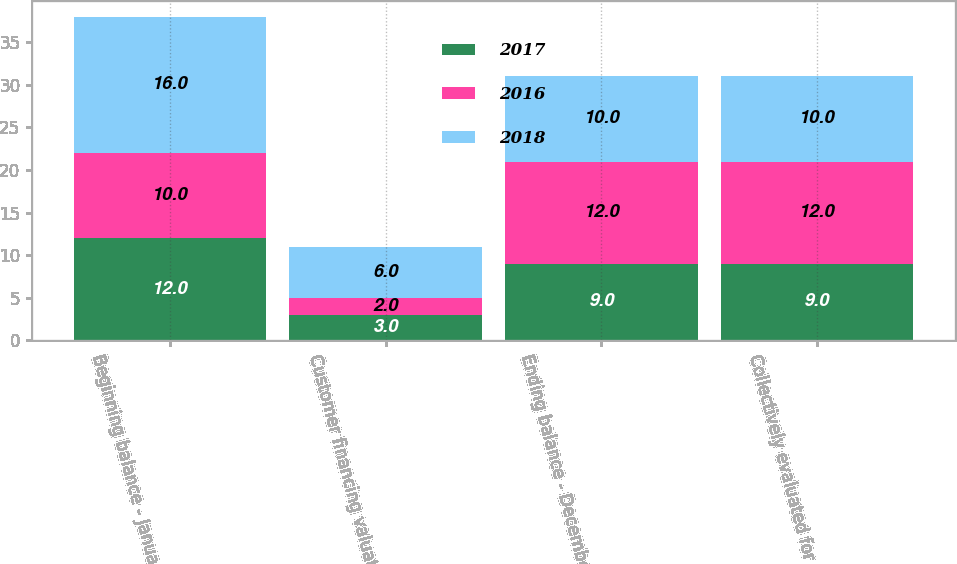<chart> <loc_0><loc_0><loc_500><loc_500><stacked_bar_chart><ecel><fcel>Beginning balance - January 1<fcel>Customer financing valuation<fcel>Ending balance - December 31<fcel>Collectively evaluated for<nl><fcel>2017<fcel>12<fcel>3<fcel>9<fcel>9<nl><fcel>2016<fcel>10<fcel>2<fcel>12<fcel>12<nl><fcel>2018<fcel>16<fcel>6<fcel>10<fcel>10<nl></chart> 